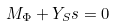<formula> <loc_0><loc_0><loc_500><loc_500>M _ { \Phi } + Y _ { S } s = 0</formula> 